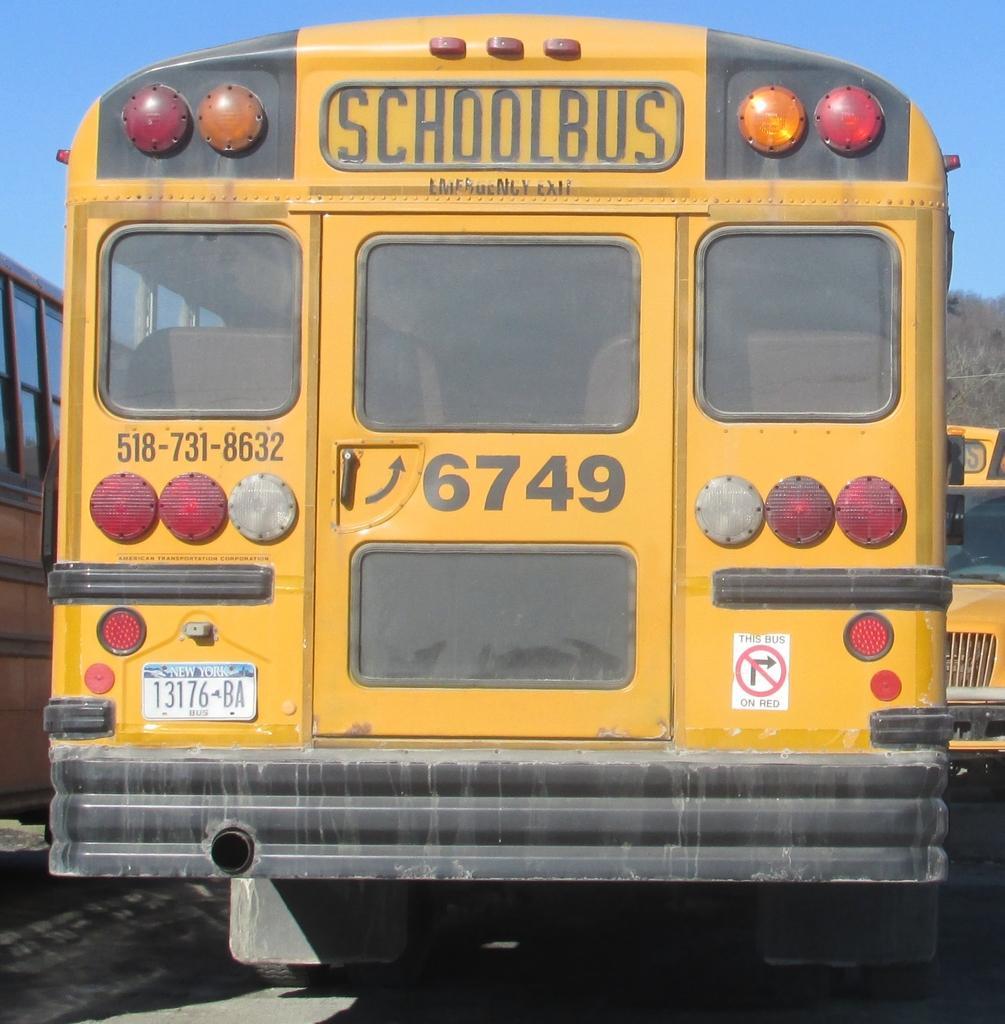Please provide a concise description of this image. In this image we can see some school buses with some texts and numbers on it, also we can see the sky. 